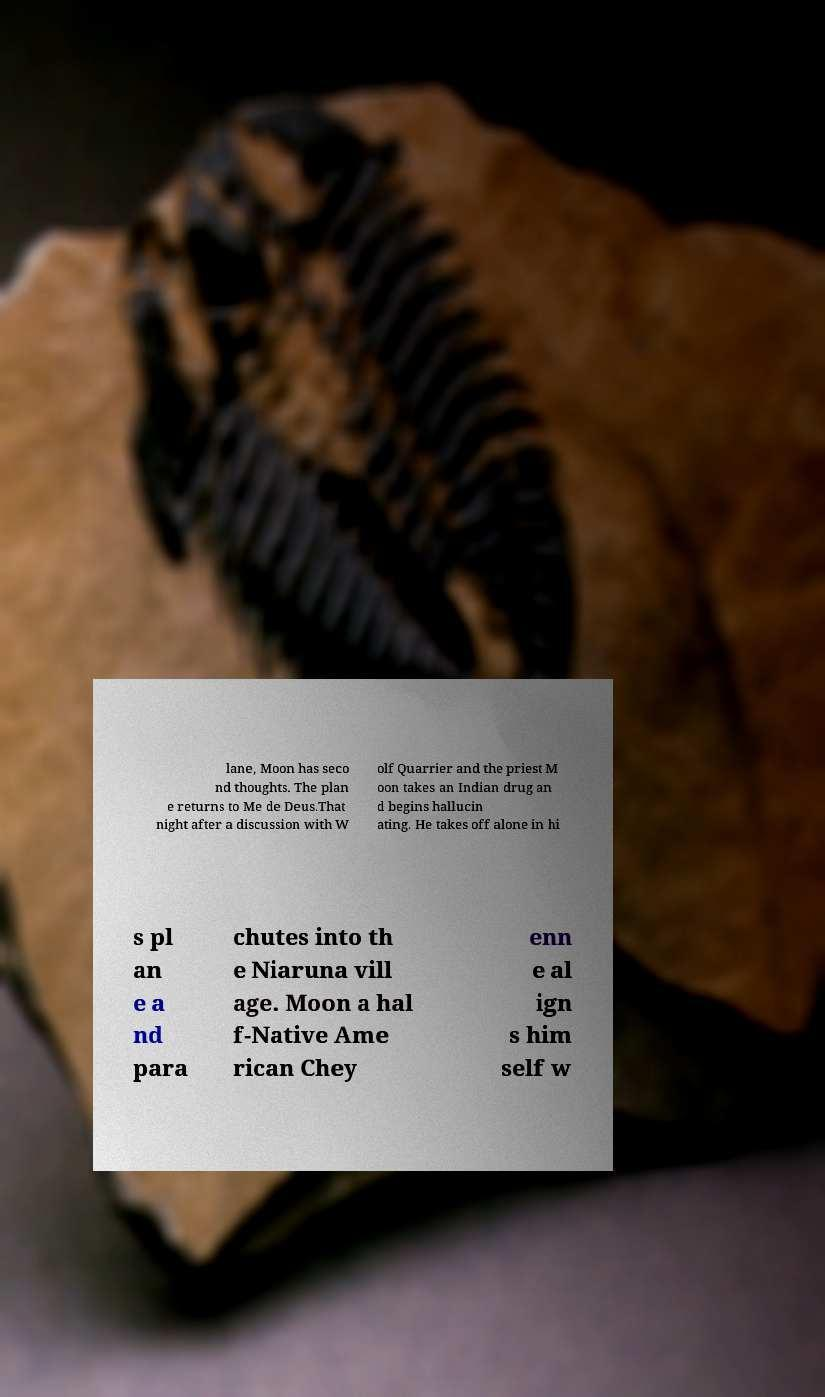Please identify and transcribe the text found in this image. lane, Moon has seco nd thoughts. The plan e returns to Me de Deus.That night after a discussion with W olf Quarrier and the priest M oon takes an Indian drug an d begins hallucin ating. He takes off alone in hi s pl an e a nd para chutes into th e Niaruna vill age. Moon a hal f-Native Ame rican Chey enn e al ign s him self w 